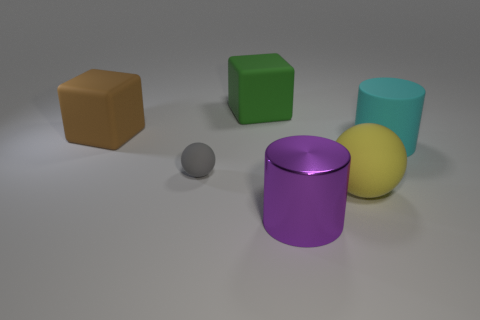There is a green object that is the same shape as the large brown matte thing; what material is it?
Give a very brief answer. Rubber. How many objects are large rubber cubes that are behind the brown rubber block or tiny cyan matte cubes?
Provide a succinct answer. 1. What shape is the big green thing that is made of the same material as the gray object?
Offer a very short reply. Cube. What number of other things are the same shape as the cyan object?
Your response must be concise. 1. What material is the large sphere?
Keep it short and to the point. Rubber. How many cylinders are gray objects or large green rubber things?
Provide a short and direct response. 0. There is a thing that is to the left of the tiny gray rubber ball; what is its color?
Provide a short and direct response. Brown. What number of other brown rubber blocks have the same size as the brown cube?
Make the answer very short. 0. There is a object that is left of the tiny sphere; is it the same shape as the matte object that is behind the large brown thing?
Your answer should be compact. Yes. What material is the cube behind the big rubber thing that is left of the large matte block that is behind the brown rubber cube?
Give a very brief answer. Rubber. 